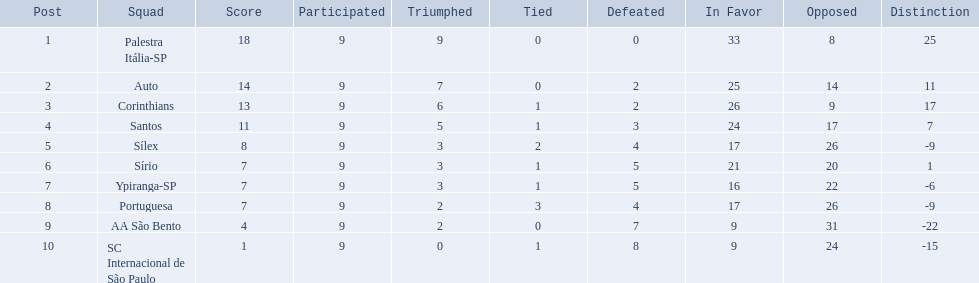What are all the teams? Palestra Itália-SP, Auto, Corinthians, Santos, Sílex, Sírio, Ypiranga-SP, Portuguesa, AA São Bento, SC Internacional de São Paulo. How many times did each team lose? 0, 2, 2, 3, 4, 5, 5, 4, 7, 8. And which team never lost? Palestra Itália-SP. 